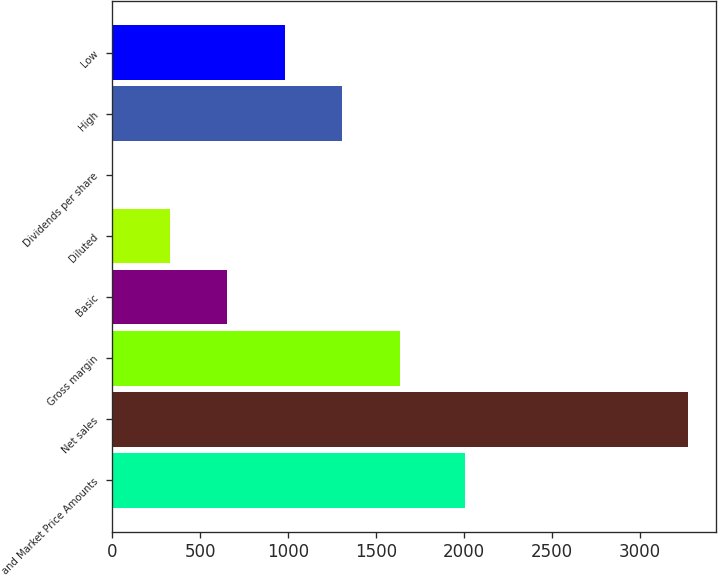Convert chart. <chart><loc_0><loc_0><loc_500><loc_500><bar_chart><fcel>and Market Price Amounts<fcel>Net sales<fcel>Gross margin<fcel>Basic<fcel>Diluted<fcel>Dividends per share<fcel>High<fcel>Low<nl><fcel>2006<fcel>3273<fcel>1636.68<fcel>654.87<fcel>327.6<fcel>0.33<fcel>1309.41<fcel>982.14<nl></chart> 